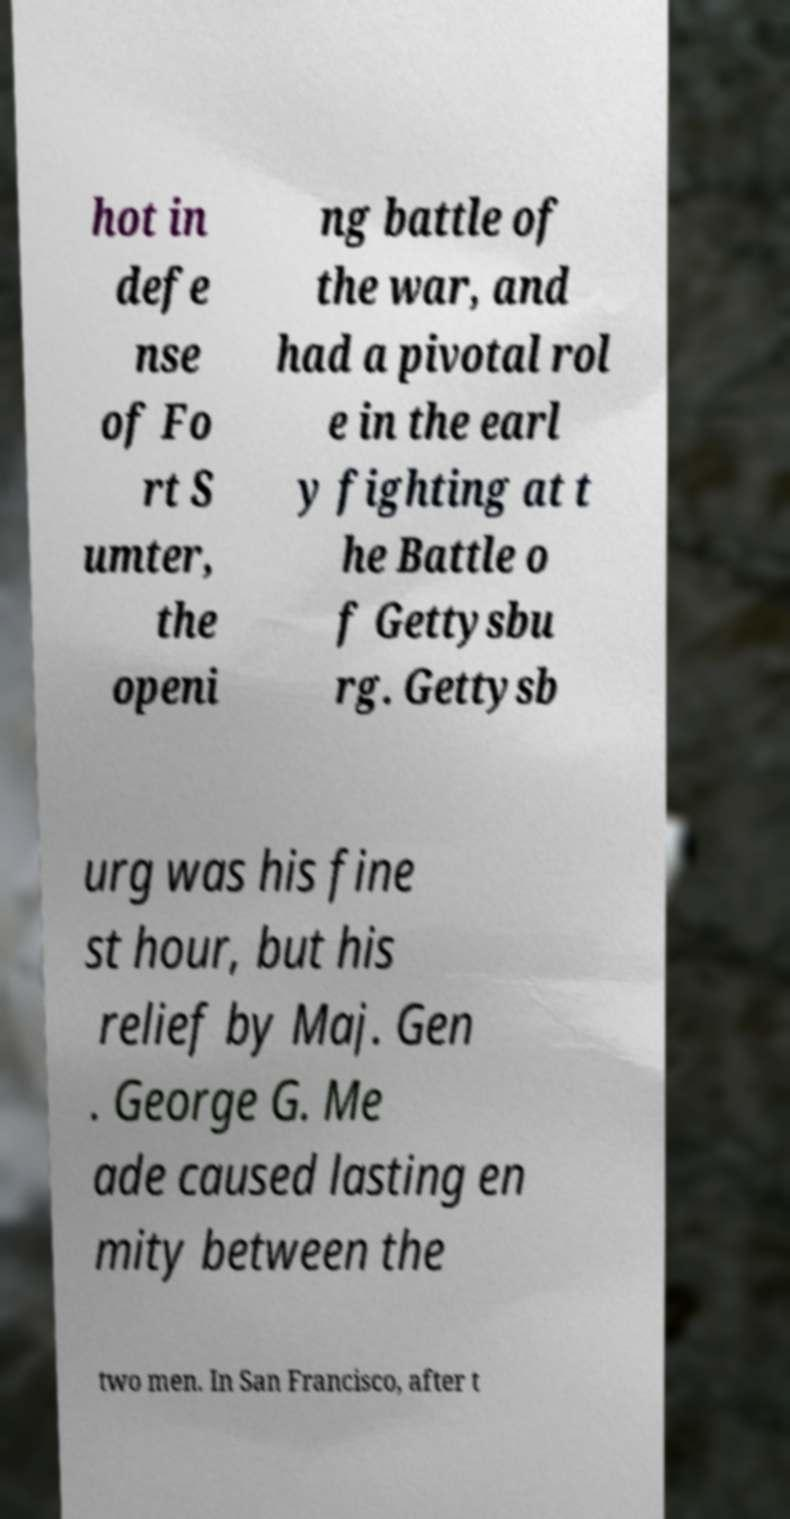Can you read and provide the text displayed in the image?This photo seems to have some interesting text. Can you extract and type it out for me? hot in defe nse of Fo rt S umter, the openi ng battle of the war, and had a pivotal rol e in the earl y fighting at t he Battle o f Gettysbu rg. Gettysb urg was his fine st hour, but his relief by Maj. Gen . George G. Me ade caused lasting en mity between the two men. In San Francisco, after t 